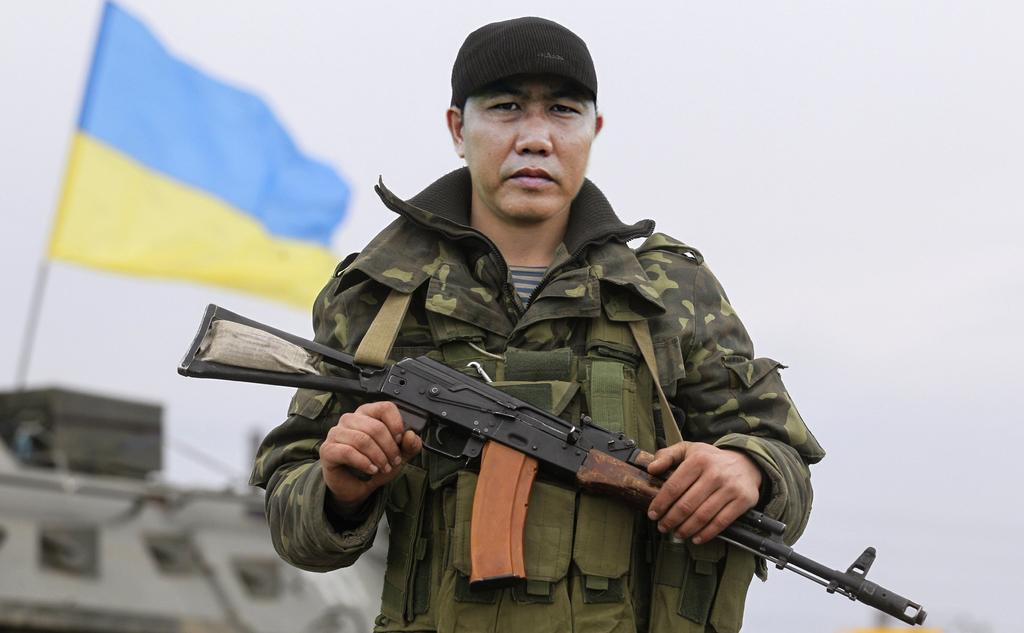What is the main subject of the image? There is a person standing in the center of the image. What is the person holding in the image? The person is holding a gun. What can be seen in the background of the image? There is a flag and a war tanker in the background of the image. What is visible in the sky in the image? The sky is visible in the background of the image. What type of parent can be seen holding the grip of the metal in the image? There is no parent or metal grip present in the image. The person is holding a gun, but it is not made of metal and there is no mention of a parent. 